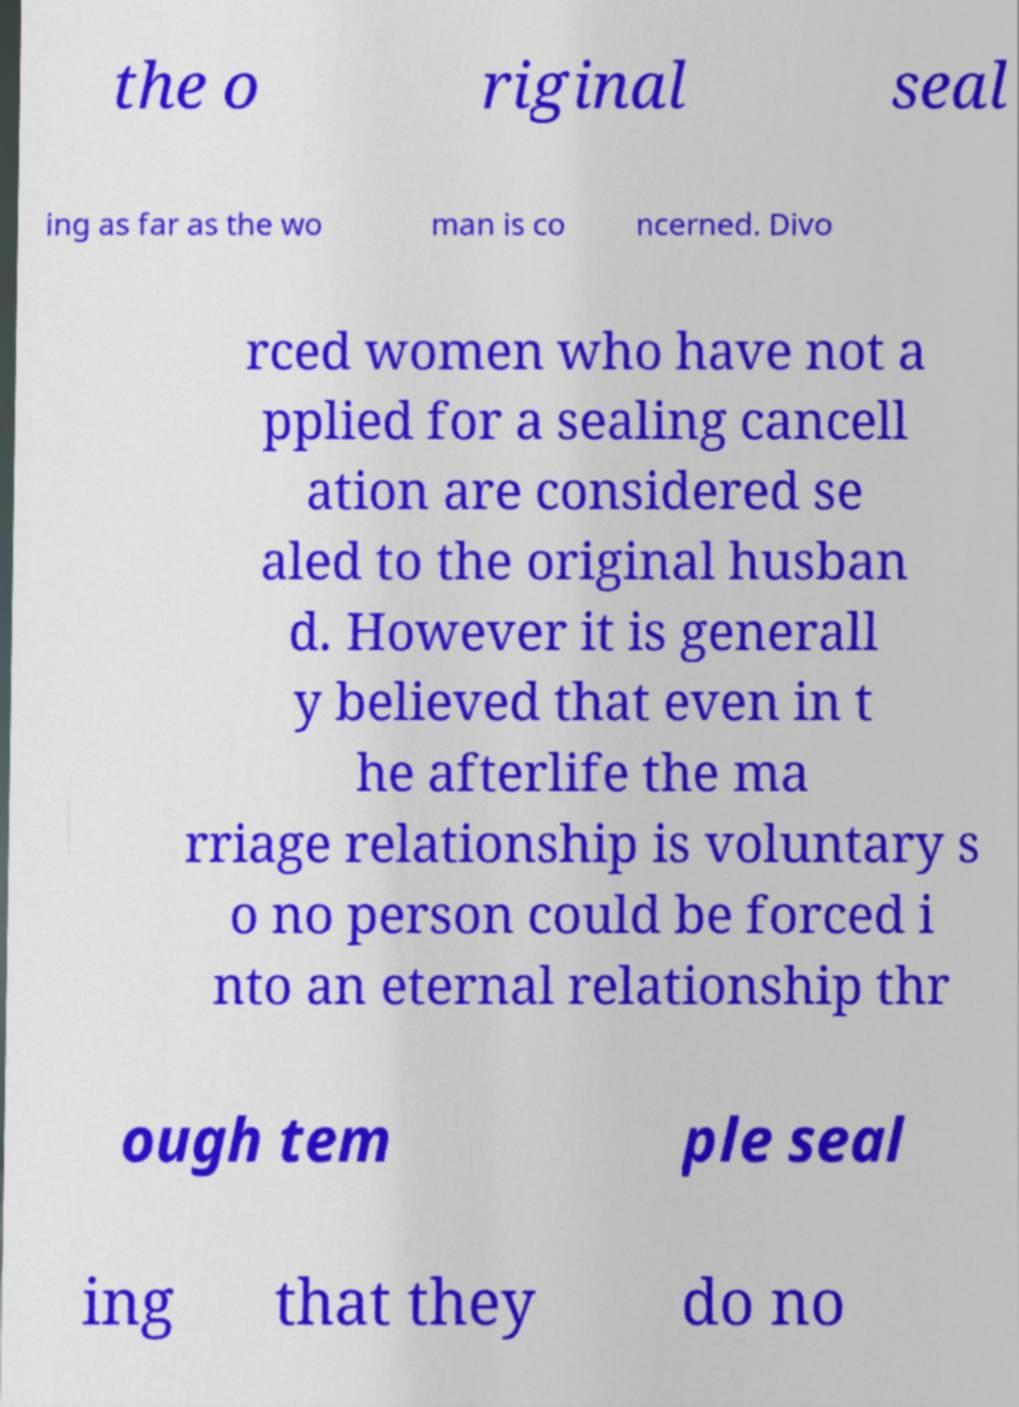Please read and relay the text visible in this image. What does it say? the o riginal seal ing as far as the wo man is co ncerned. Divo rced women who have not a pplied for a sealing cancell ation are considered se aled to the original husban d. However it is generall y believed that even in t he afterlife the ma rriage relationship is voluntary s o no person could be forced i nto an eternal relationship thr ough tem ple seal ing that they do no 